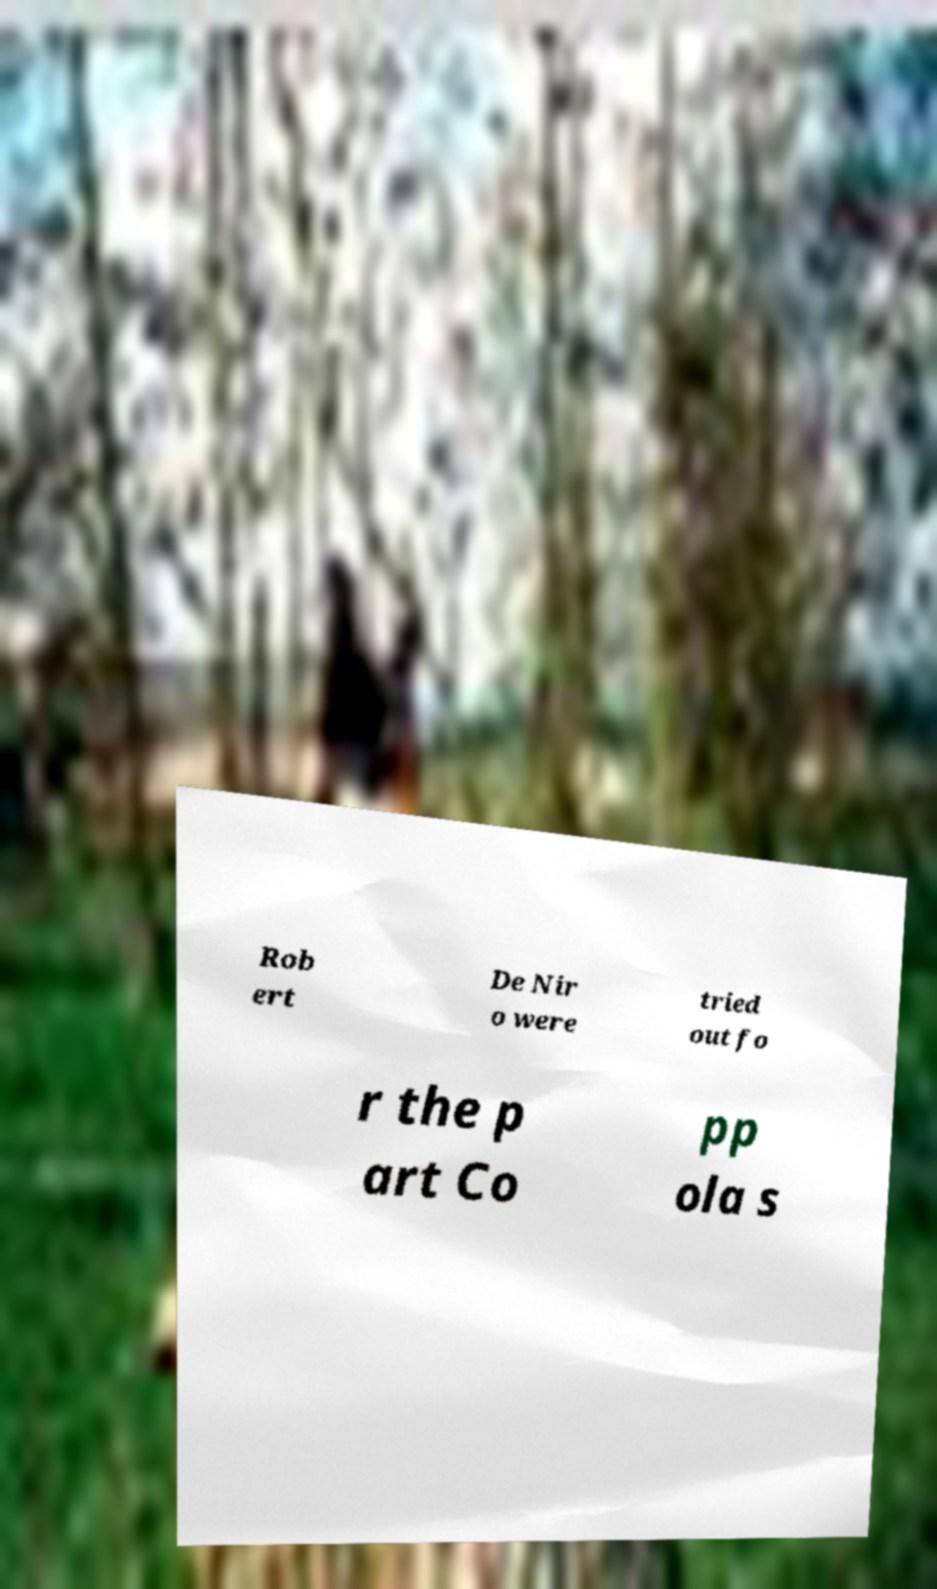What messages or text are displayed in this image? I need them in a readable, typed format. Rob ert De Nir o were tried out fo r the p art Co pp ola s 